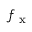<formula> <loc_0><loc_0><loc_500><loc_500>f _ { x }</formula> 